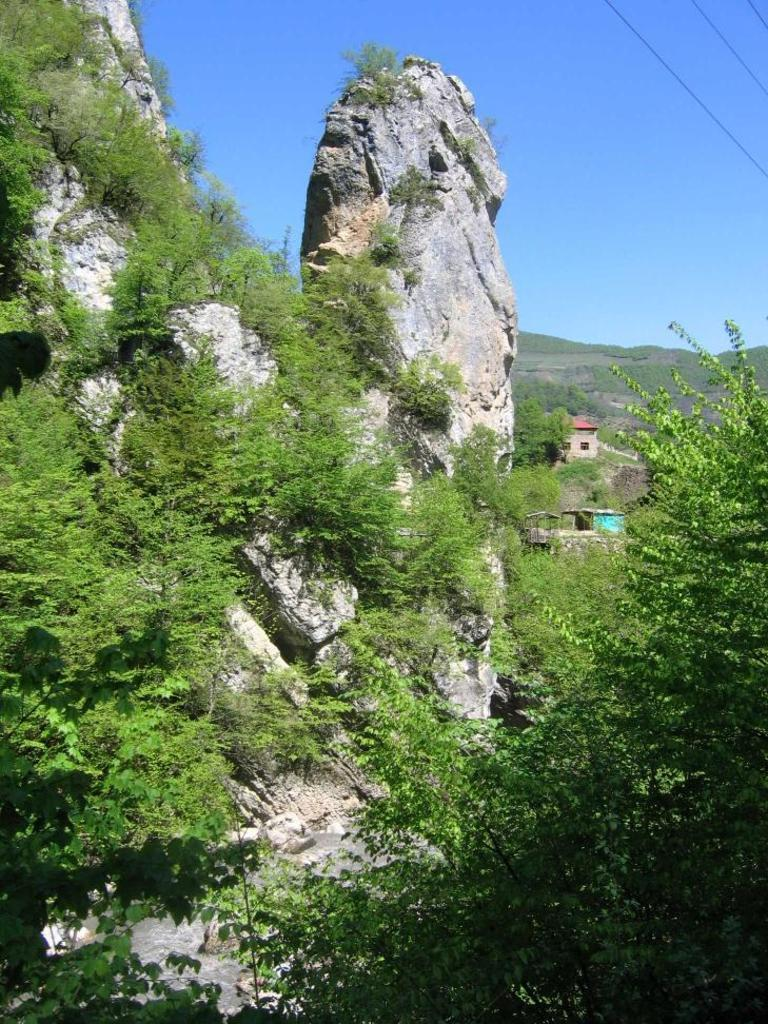What is the main subject in the middle of the image? There is a rock in the middle of the image. What type of vegetation is on the right side of the image? There are plants on the right side of the image. What can be seen in the background of the image? The sky is visible in the background of the image. What time of day is it in the image, and how many apples are on the rock? The time of day is not mentioned in the image, and there are no apples present. 